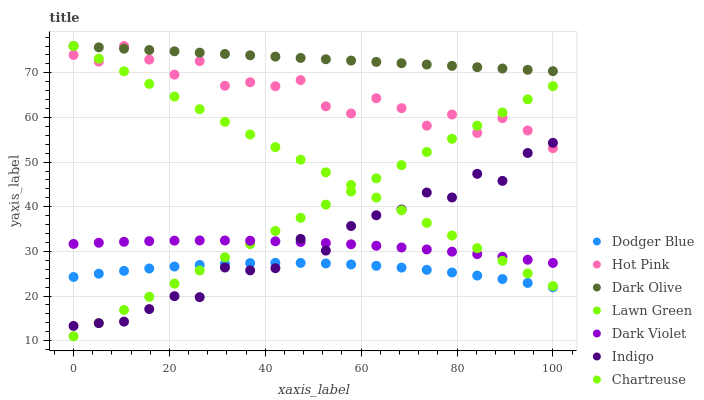Does Dodger Blue have the minimum area under the curve?
Answer yes or no. Yes. Does Dark Olive have the maximum area under the curve?
Answer yes or no. Yes. Does Hot Pink have the minimum area under the curve?
Answer yes or no. No. Does Hot Pink have the maximum area under the curve?
Answer yes or no. No. Is Lawn Green the smoothest?
Answer yes or no. Yes. Is Hot Pink the roughest?
Answer yes or no. Yes. Is Indigo the smoothest?
Answer yes or no. No. Is Indigo the roughest?
Answer yes or no. No. Does Lawn Green have the lowest value?
Answer yes or no. Yes. Does Hot Pink have the lowest value?
Answer yes or no. No. Does Chartreuse have the highest value?
Answer yes or no. Yes. Does Indigo have the highest value?
Answer yes or no. No. Is Dark Violet less than Hot Pink?
Answer yes or no. Yes. Is Hot Pink greater than Dodger Blue?
Answer yes or no. Yes. Does Chartreuse intersect Dark Olive?
Answer yes or no. Yes. Is Chartreuse less than Dark Olive?
Answer yes or no. No. Is Chartreuse greater than Dark Olive?
Answer yes or no. No. Does Dark Violet intersect Hot Pink?
Answer yes or no. No. 